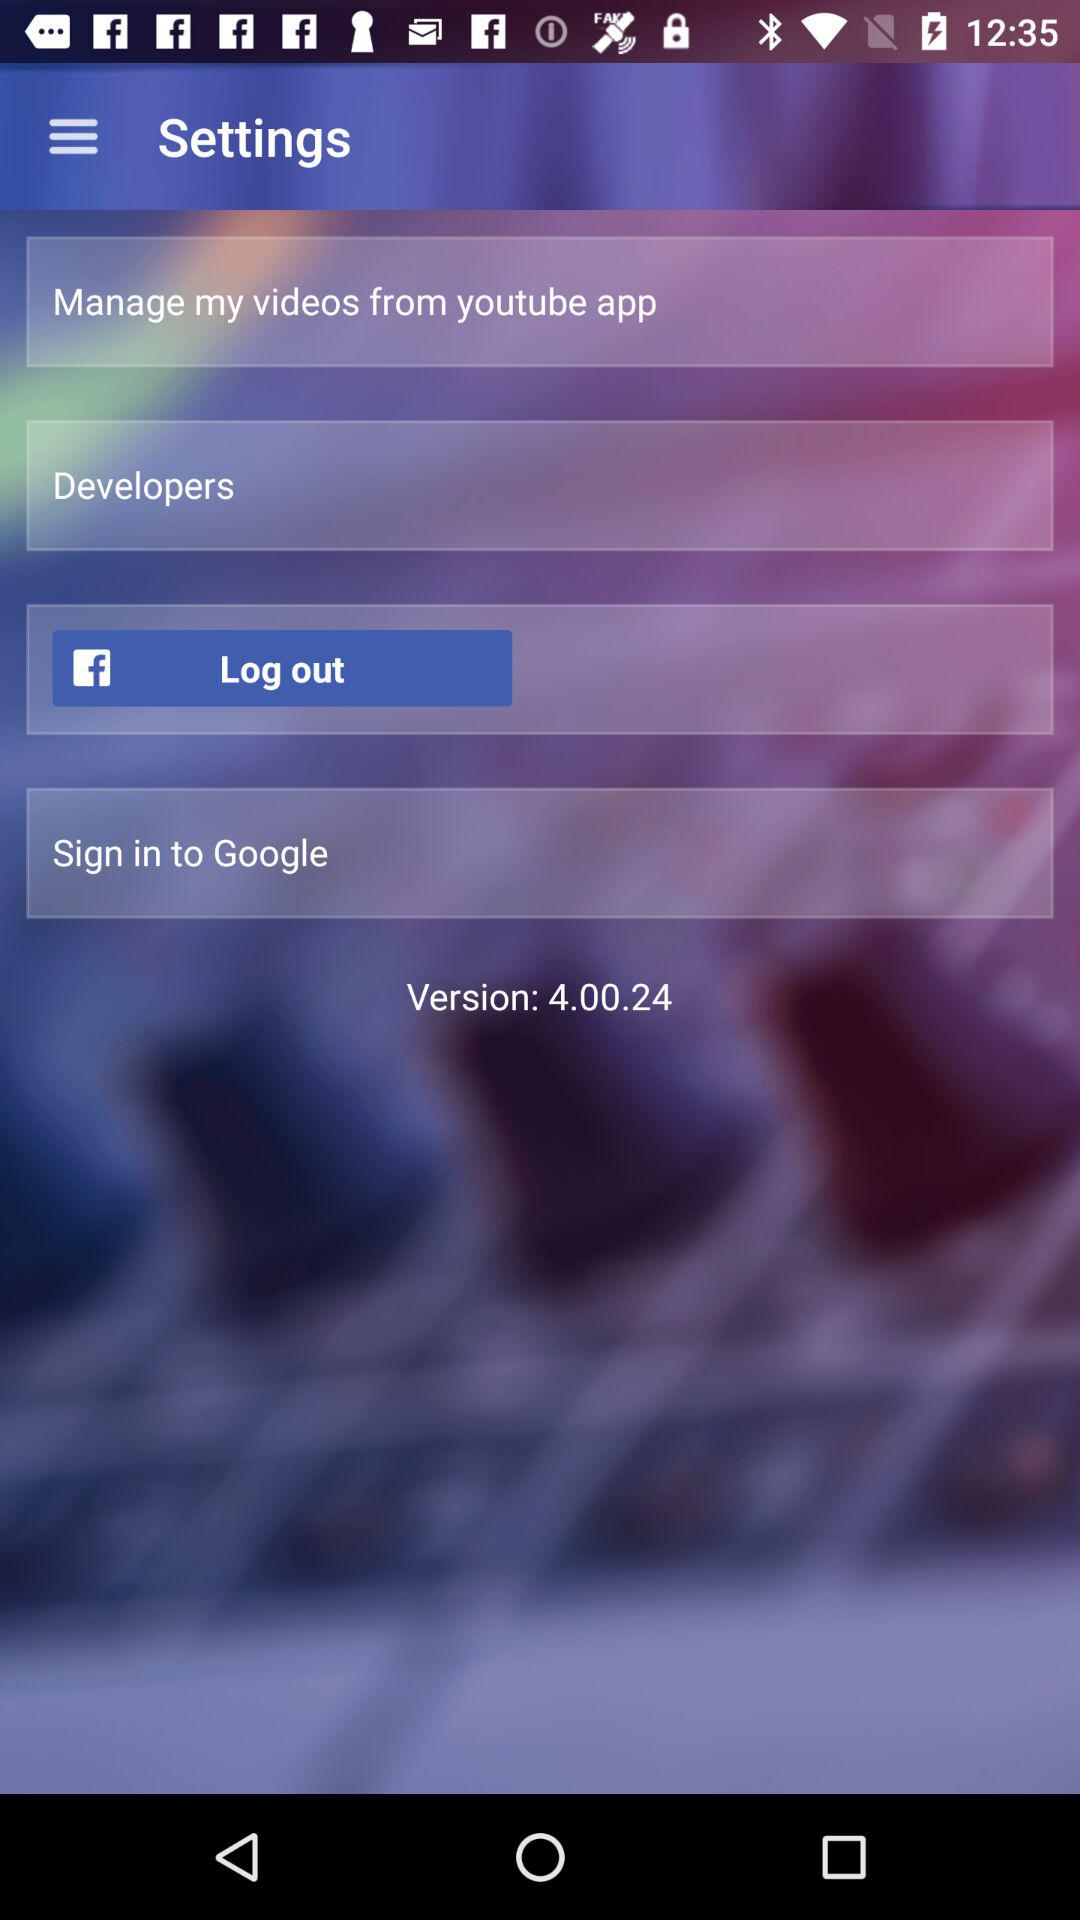What application allows me to log out? The application is "Facebook". 